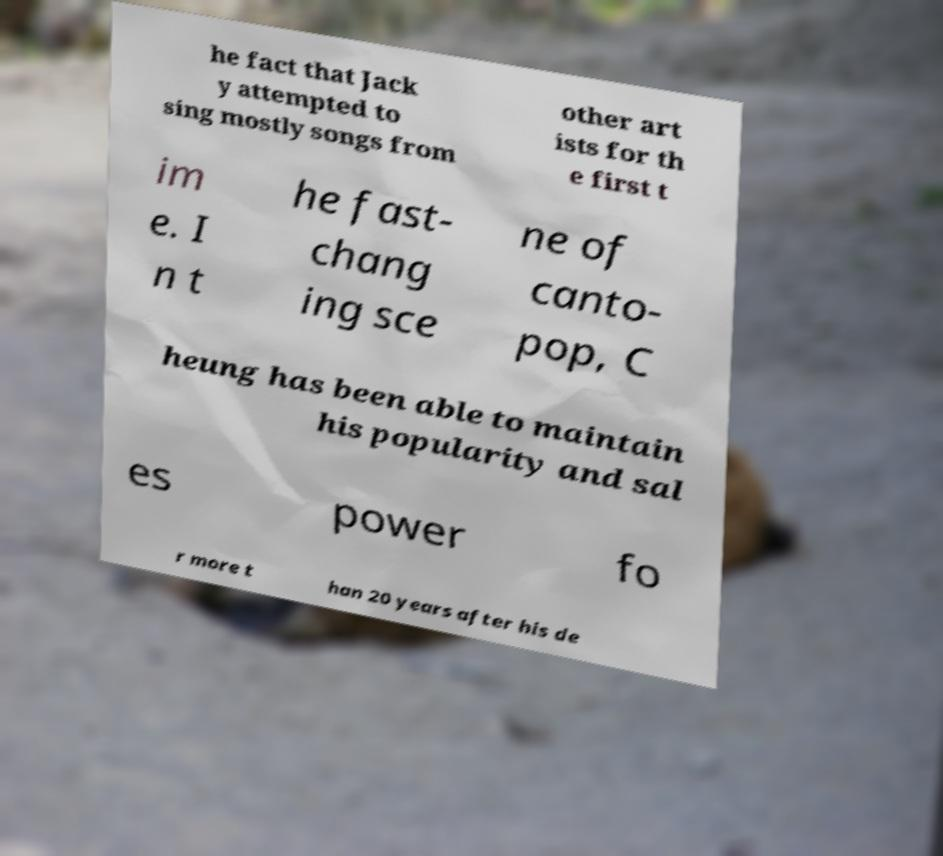Can you accurately transcribe the text from the provided image for me? he fact that Jack y attempted to sing mostly songs from other art ists for th e first t im e. I n t he fast- chang ing sce ne of canto- pop, C heung has been able to maintain his popularity and sal es power fo r more t han 20 years after his de 